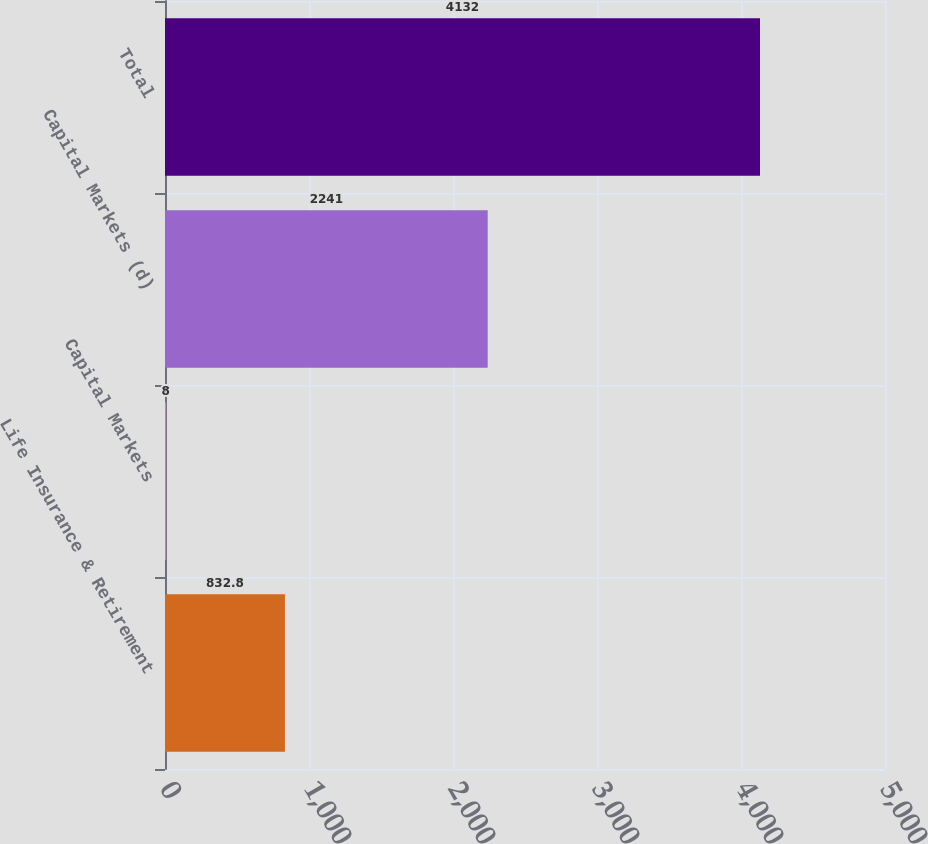Convert chart. <chart><loc_0><loc_0><loc_500><loc_500><bar_chart><fcel>Life Insurance & Retirement<fcel>Capital Markets<fcel>Capital Markets (d)<fcel>Total<nl><fcel>832.8<fcel>8<fcel>2241<fcel>4132<nl></chart> 